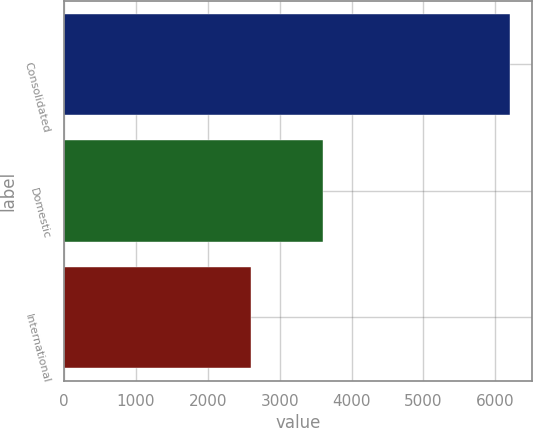Convert chart to OTSL. <chart><loc_0><loc_0><loc_500><loc_500><bar_chart><fcel>Consolidated<fcel>Domestic<fcel>International<nl><fcel>6201.4<fcel>3600.3<fcel>2601.1<nl></chart> 